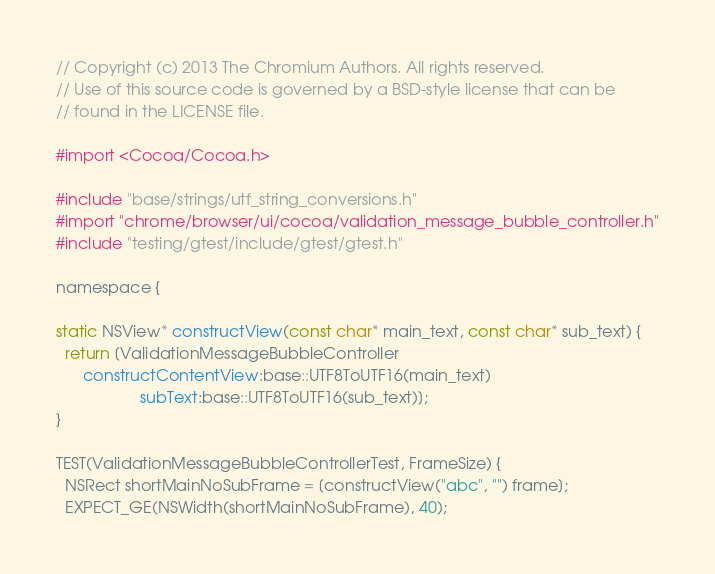<code> <loc_0><loc_0><loc_500><loc_500><_ObjectiveC_>// Copyright (c) 2013 The Chromium Authors. All rights reserved.
// Use of this source code is governed by a BSD-style license that can be
// found in the LICENSE file.

#import <Cocoa/Cocoa.h>

#include "base/strings/utf_string_conversions.h"
#import "chrome/browser/ui/cocoa/validation_message_bubble_controller.h"
#include "testing/gtest/include/gtest/gtest.h"

namespace {

static NSView* constructView(const char* main_text, const char* sub_text) {
  return [ValidationMessageBubbleController
      constructContentView:base::UTF8ToUTF16(main_text)
                   subText:base::UTF8ToUTF16(sub_text)];
}

TEST(ValidationMessageBubbleControllerTest, FrameSize) {
  NSRect shortMainNoSubFrame = [constructView("abc", "") frame];
  EXPECT_GE(NSWidth(shortMainNoSubFrame), 40);</code> 